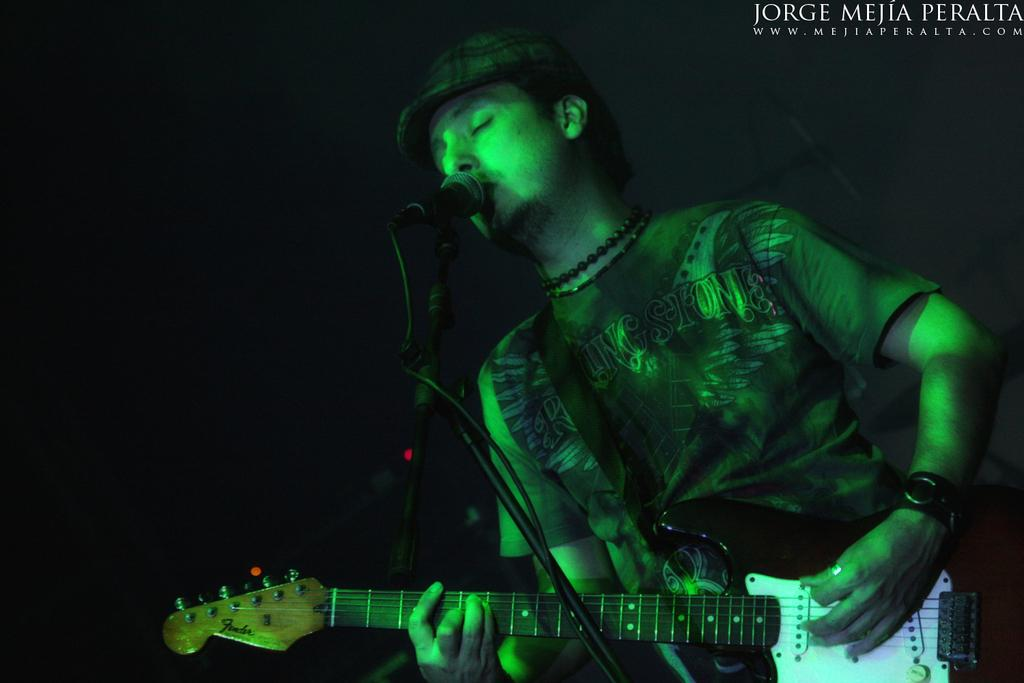Who is in the image? There is a man in the image. What is the man holding in the image? The man is holding a guitar. What is the man doing with the guitar? The man is playing the guitar. What other object is present in the image? There is a microphone in the image. What type of cork can be seen on the wall in the image? There is no cork present on the wall in the image. 